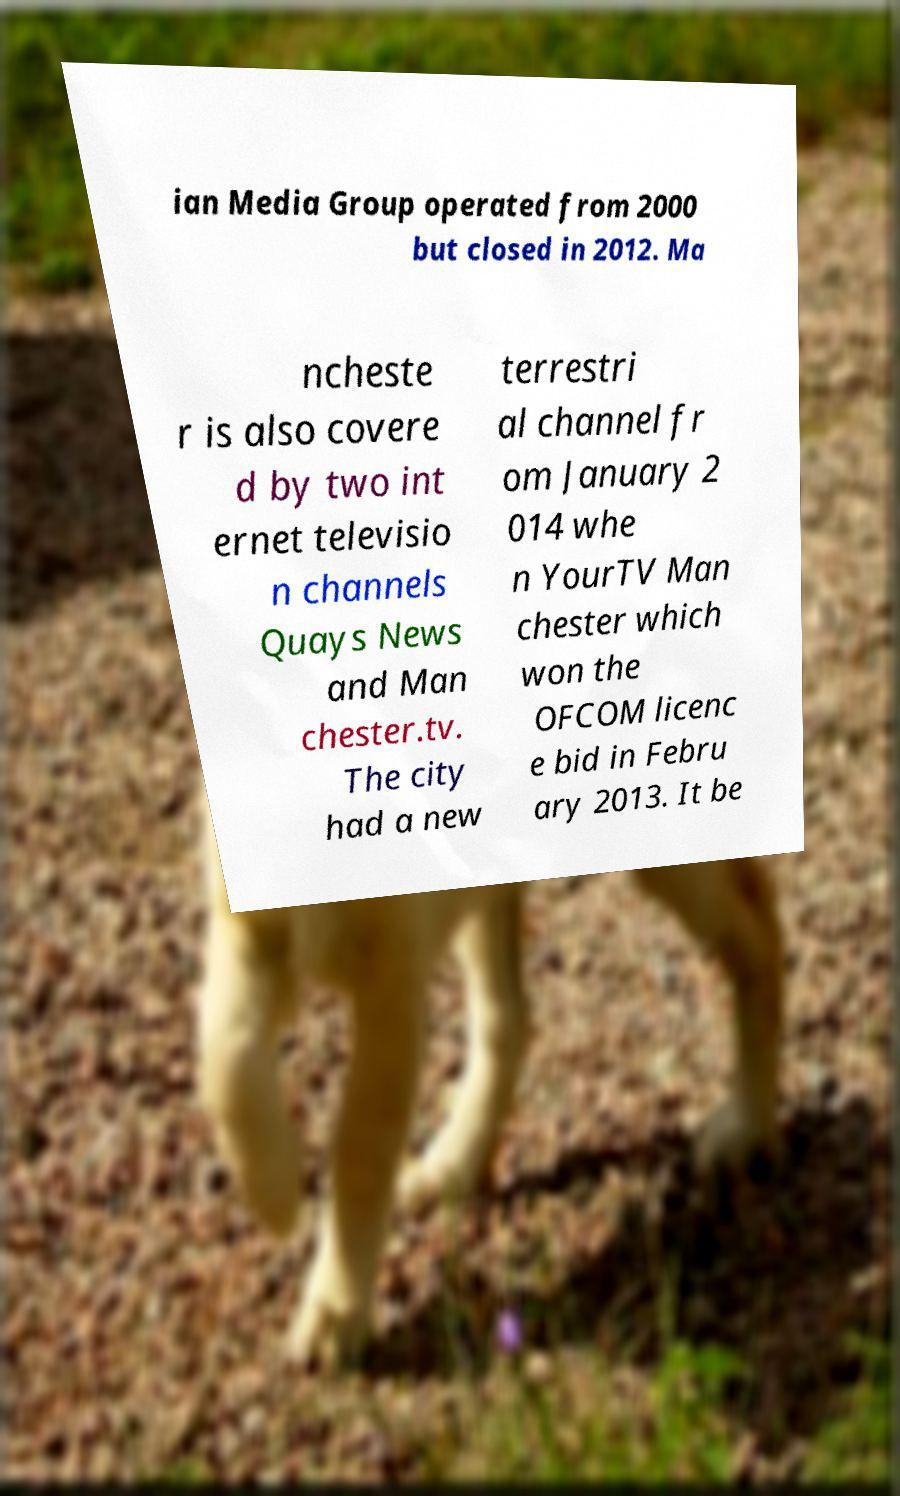What messages or text are displayed in this image? I need them in a readable, typed format. ian Media Group operated from 2000 but closed in 2012. Ma ncheste r is also covere d by two int ernet televisio n channels Quays News and Man chester.tv. The city had a new terrestri al channel fr om January 2 014 whe n YourTV Man chester which won the OFCOM licenc e bid in Febru ary 2013. It be 